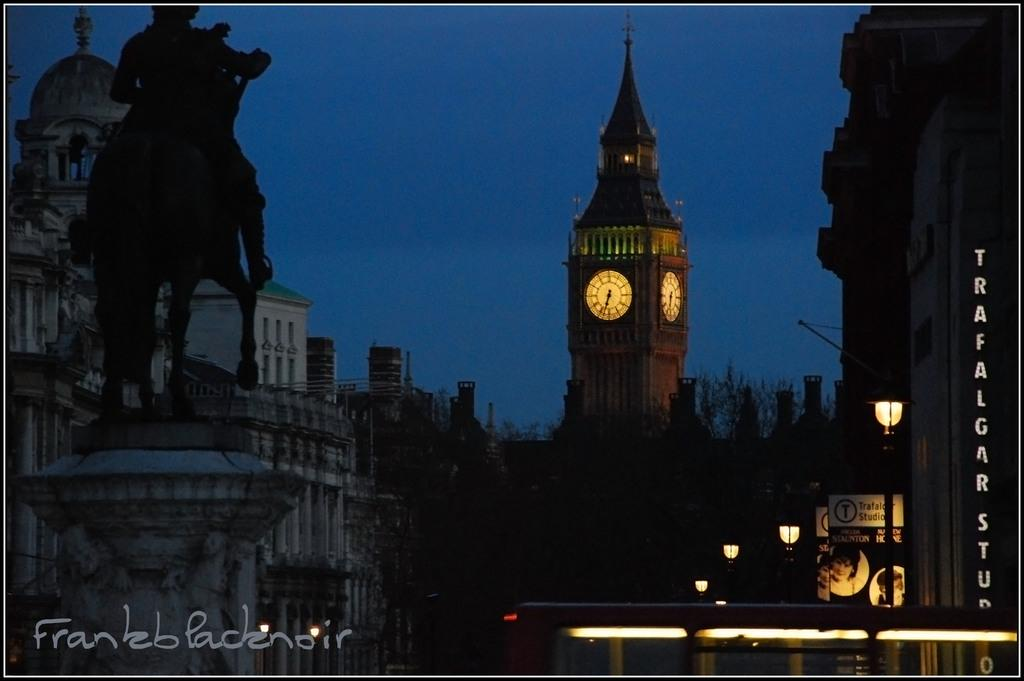What type of structures can be seen in the image? There are buildings in the image. What other objects are present in the image? There are poles, boards, and lights visible in the image. What specific feature can be identified among the buildings? There is a clock tower in the image. What can be seen in the background of the image? The sky is visible in the background of the image. How many clovers are growing on the roof of the building in the image? There are no clovers visible on the roof of the building in the image. What type of payment is being made in the image? There is no payment being made in the image; it features buildings, poles, boards, lights, and a clock tower. 